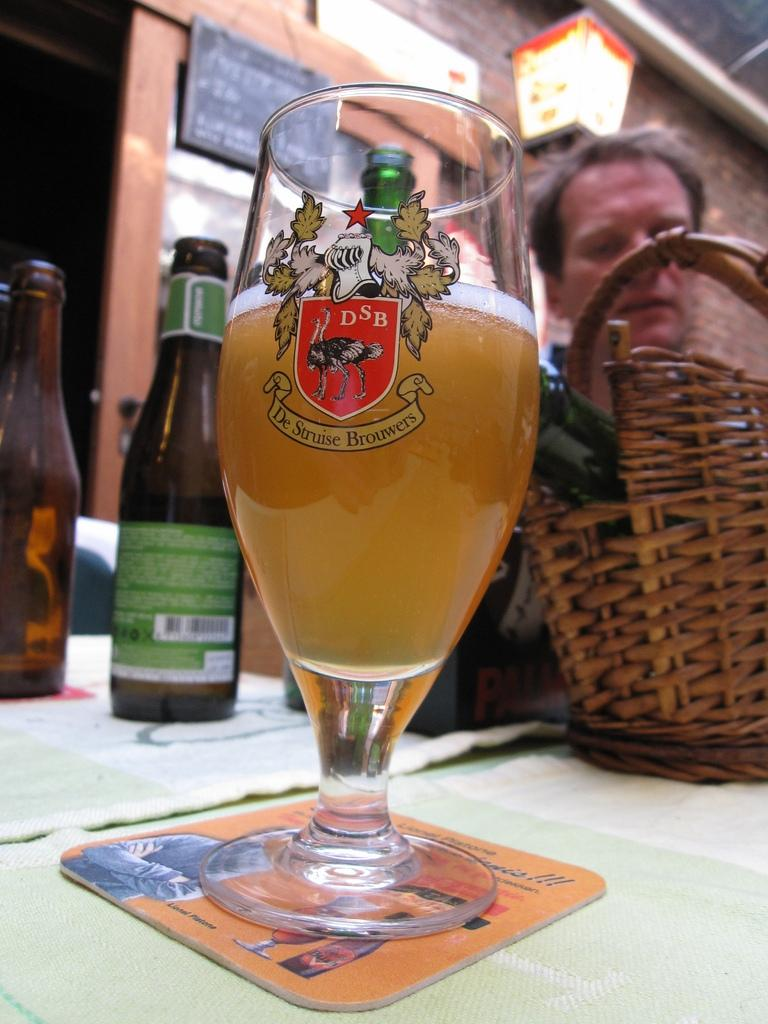What is in the glass that is visible in the image? There is a glass of wine in the image. Besides the wine glass, what other wine-related items can be seen in the image? There are wine bottles in the image. Where are the wine glass and bottles located in the image? The wine glass and bottles are on a table in the image. Who is visible in the image? There is a person visible in the image. What decision does the person make regarding the fifth wine bottle in the image? There is no mention of a fifth wine bottle or any decision-making process in the image. 